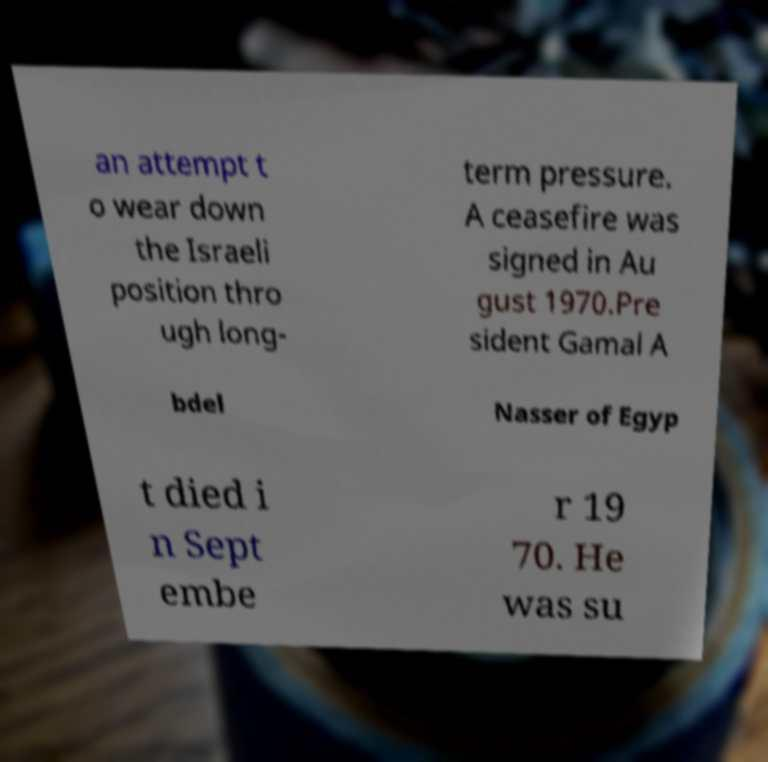What messages or text are displayed in this image? I need them in a readable, typed format. an attempt t o wear down the Israeli position thro ugh long- term pressure. A ceasefire was signed in Au gust 1970.Pre sident Gamal A bdel Nasser of Egyp t died i n Sept embe r 19 70. He was su 